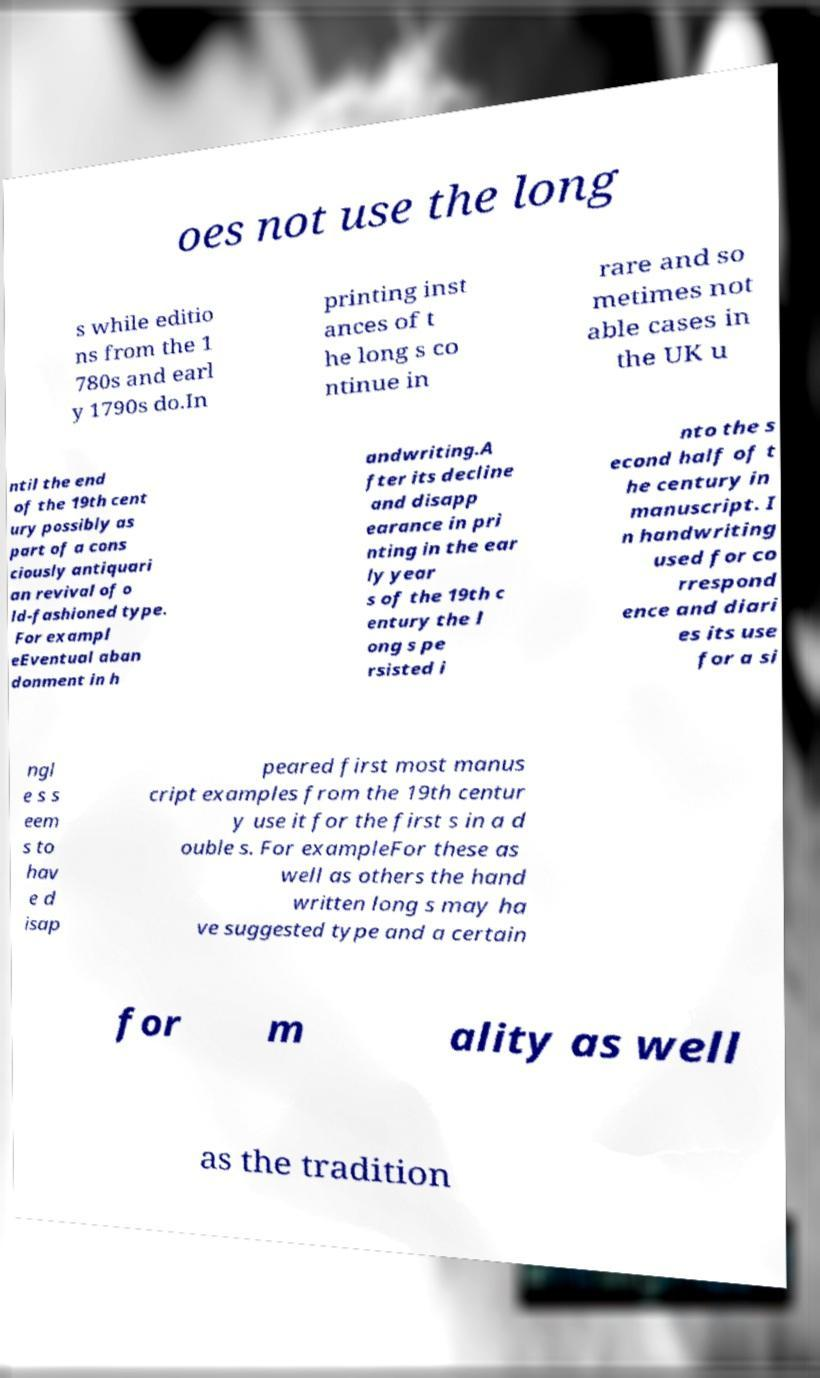I need the written content from this picture converted into text. Can you do that? oes not use the long s while editio ns from the 1 780s and earl y 1790s do.In printing inst ances of t he long s co ntinue in rare and so metimes not able cases in the UK u ntil the end of the 19th cent ury possibly as part of a cons ciously antiquari an revival of o ld-fashioned type. For exampl eEventual aban donment in h andwriting.A fter its decline and disapp earance in pri nting in the ear ly year s of the 19th c entury the l ong s pe rsisted i nto the s econd half of t he century in manuscript. I n handwriting used for co rrespond ence and diari es its use for a si ngl e s s eem s to hav e d isap peared first most manus cript examples from the 19th centur y use it for the first s in a d ouble s. For exampleFor these as well as others the hand written long s may ha ve suggested type and a certain for m ality as well as the tradition 